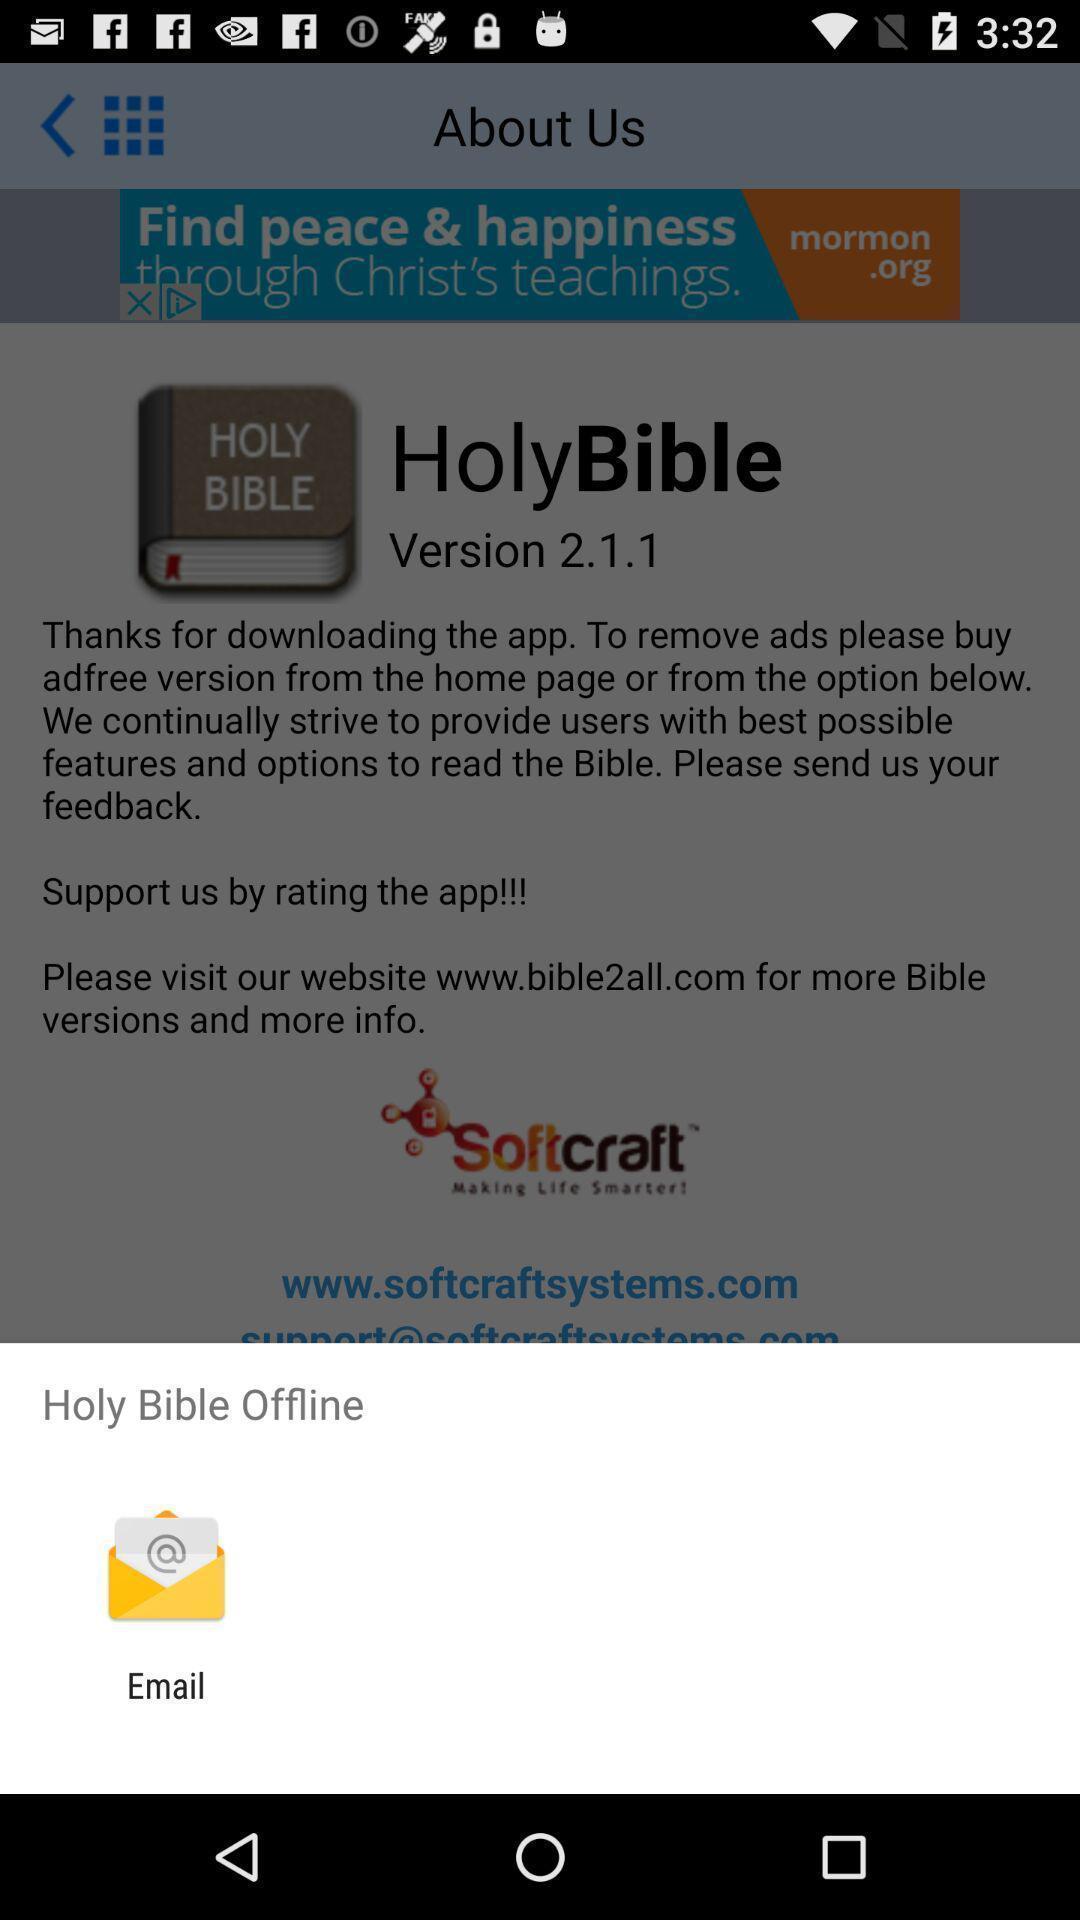Provide a description of this screenshot. Pop-up showing. 